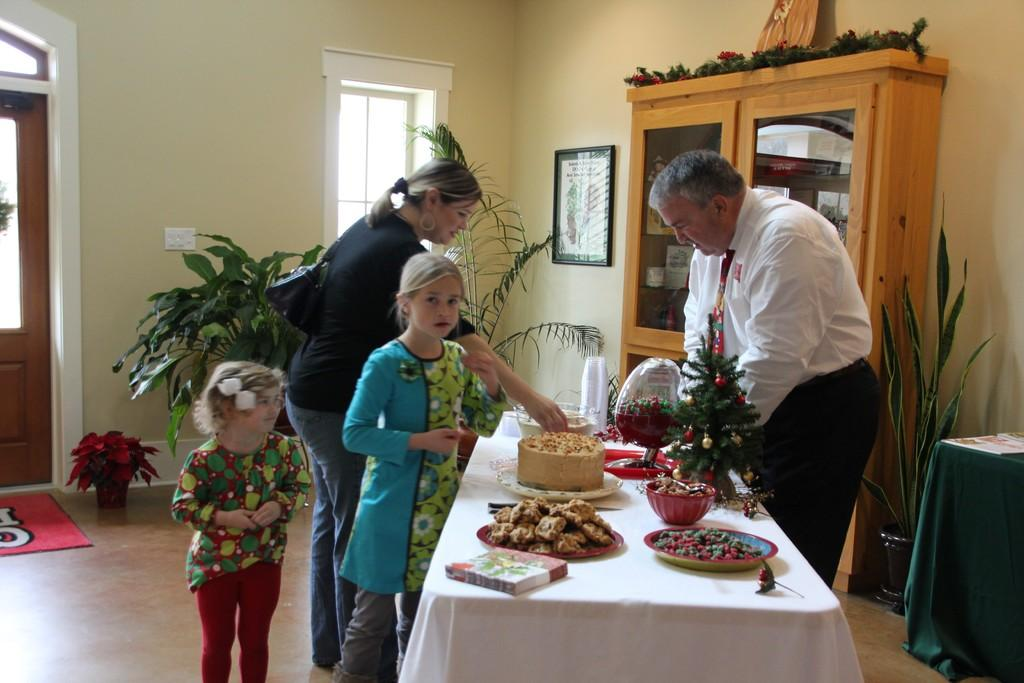How many people are in the image? There are four people in the image: a man, a woman, and two children. What are the people in the image doing? The people are standing. What can be seen on the table in the image? There are cookies and cake on the table. What type of vegetation is present in the image? There are plants in the image. What type of furniture is visible in the image? There is a cupboard in the image. What is hanging on the wall in the image? There is a photo frame on the wall. What type of pets are visible in the image? There are no pets visible in the image. What is the tendency of the moon in the image? The moon is not present in the image, so it does not have a tendency. 